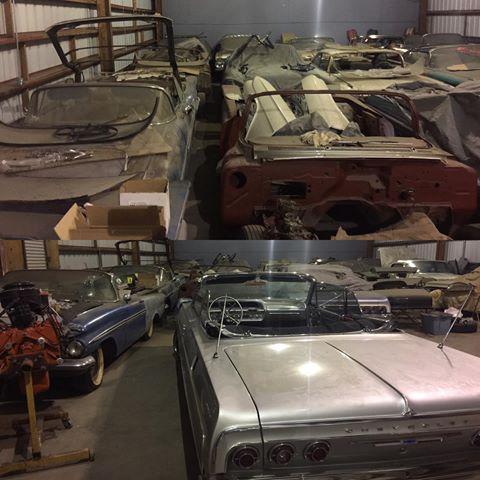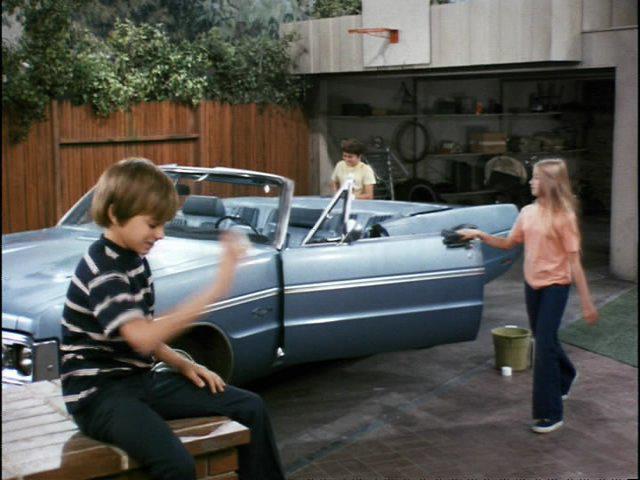The first image is the image on the left, the second image is the image on the right. For the images displayed, is the sentence "in the left image there is a sidewalk to the left of the car" factually correct? Answer yes or no. No. 